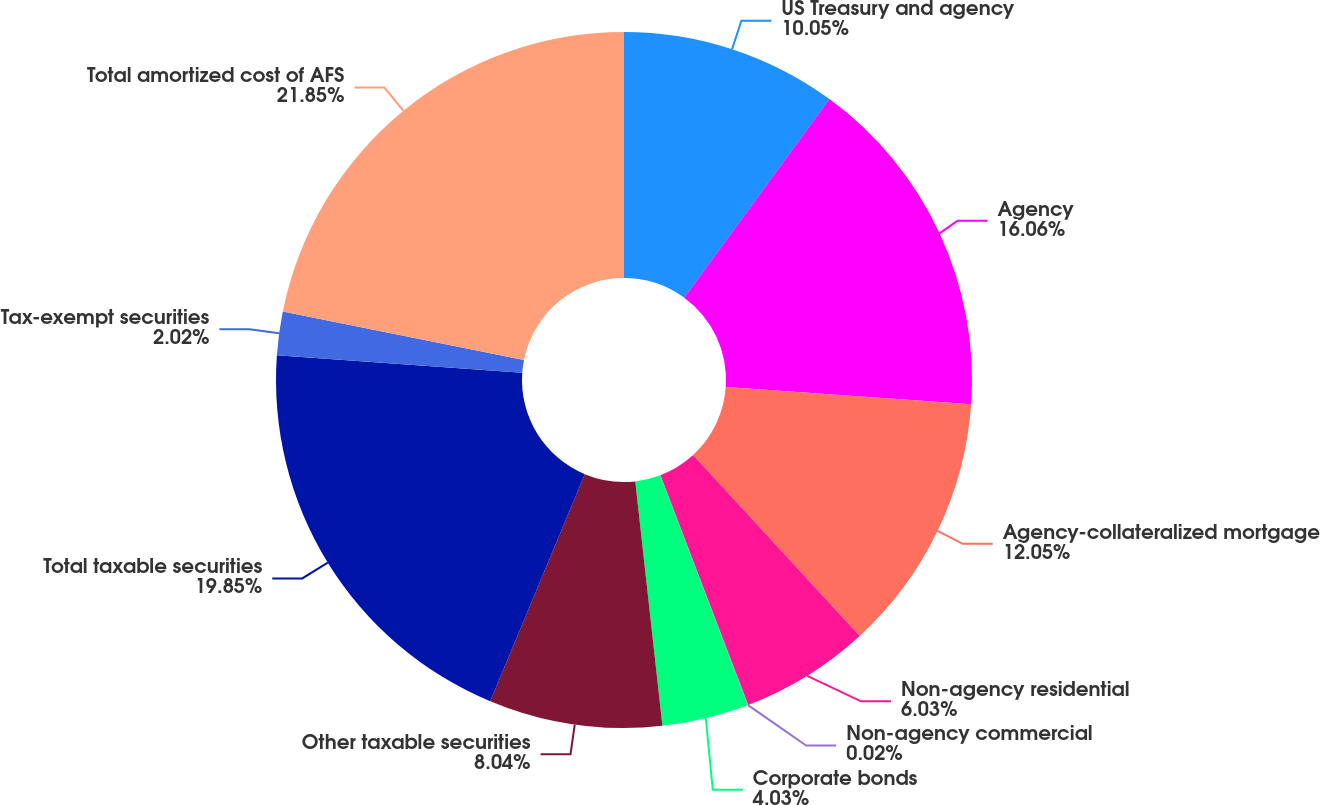Convert chart to OTSL. <chart><loc_0><loc_0><loc_500><loc_500><pie_chart><fcel>US Treasury and agency<fcel>Agency<fcel>Agency-collateralized mortgage<fcel>Non-agency residential<fcel>Non-agency commercial<fcel>Corporate bonds<fcel>Other taxable securities<fcel>Total taxable securities<fcel>Tax-exempt securities<fcel>Total amortized cost of AFS<nl><fcel>10.05%<fcel>16.06%<fcel>12.05%<fcel>6.03%<fcel>0.02%<fcel>4.03%<fcel>8.04%<fcel>19.85%<fcel>2.02%<fcel>21.85%<nl></chart> 